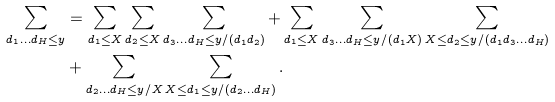Convert formula to latex. <formula><loc_0><loc_0><loc_500><loc_500>\sum _ { d _ { 1 } \dots d _ { H } \leq y } & = \sum _ { d _ { 1 } \leq X } \sum _ { d _ { 2 } \leq X } \sum _ { d _ { 3 } \dots d _ { H } \leq y / ( d _ { 1 } d _ { 2 } ) } + \sum _ { d _ { 1 } \leq X } \sum _ { d _ { 3 } \dots d _ { H } \leq y / ( d _ { 1 } X ) } \sum _ { X \leq d _ { 2 } \leq y / ( d _ { 1 } d _ { 3 } \dots d _ { H } ) } \\ & + \sum _ { d _ { 2 } \dots d _ { H } \leq y / X } \sum _ { X \leq d _ { 1 } \leq y / ( d _ { 2 } \dots d _ { H } ) } .</formula> 